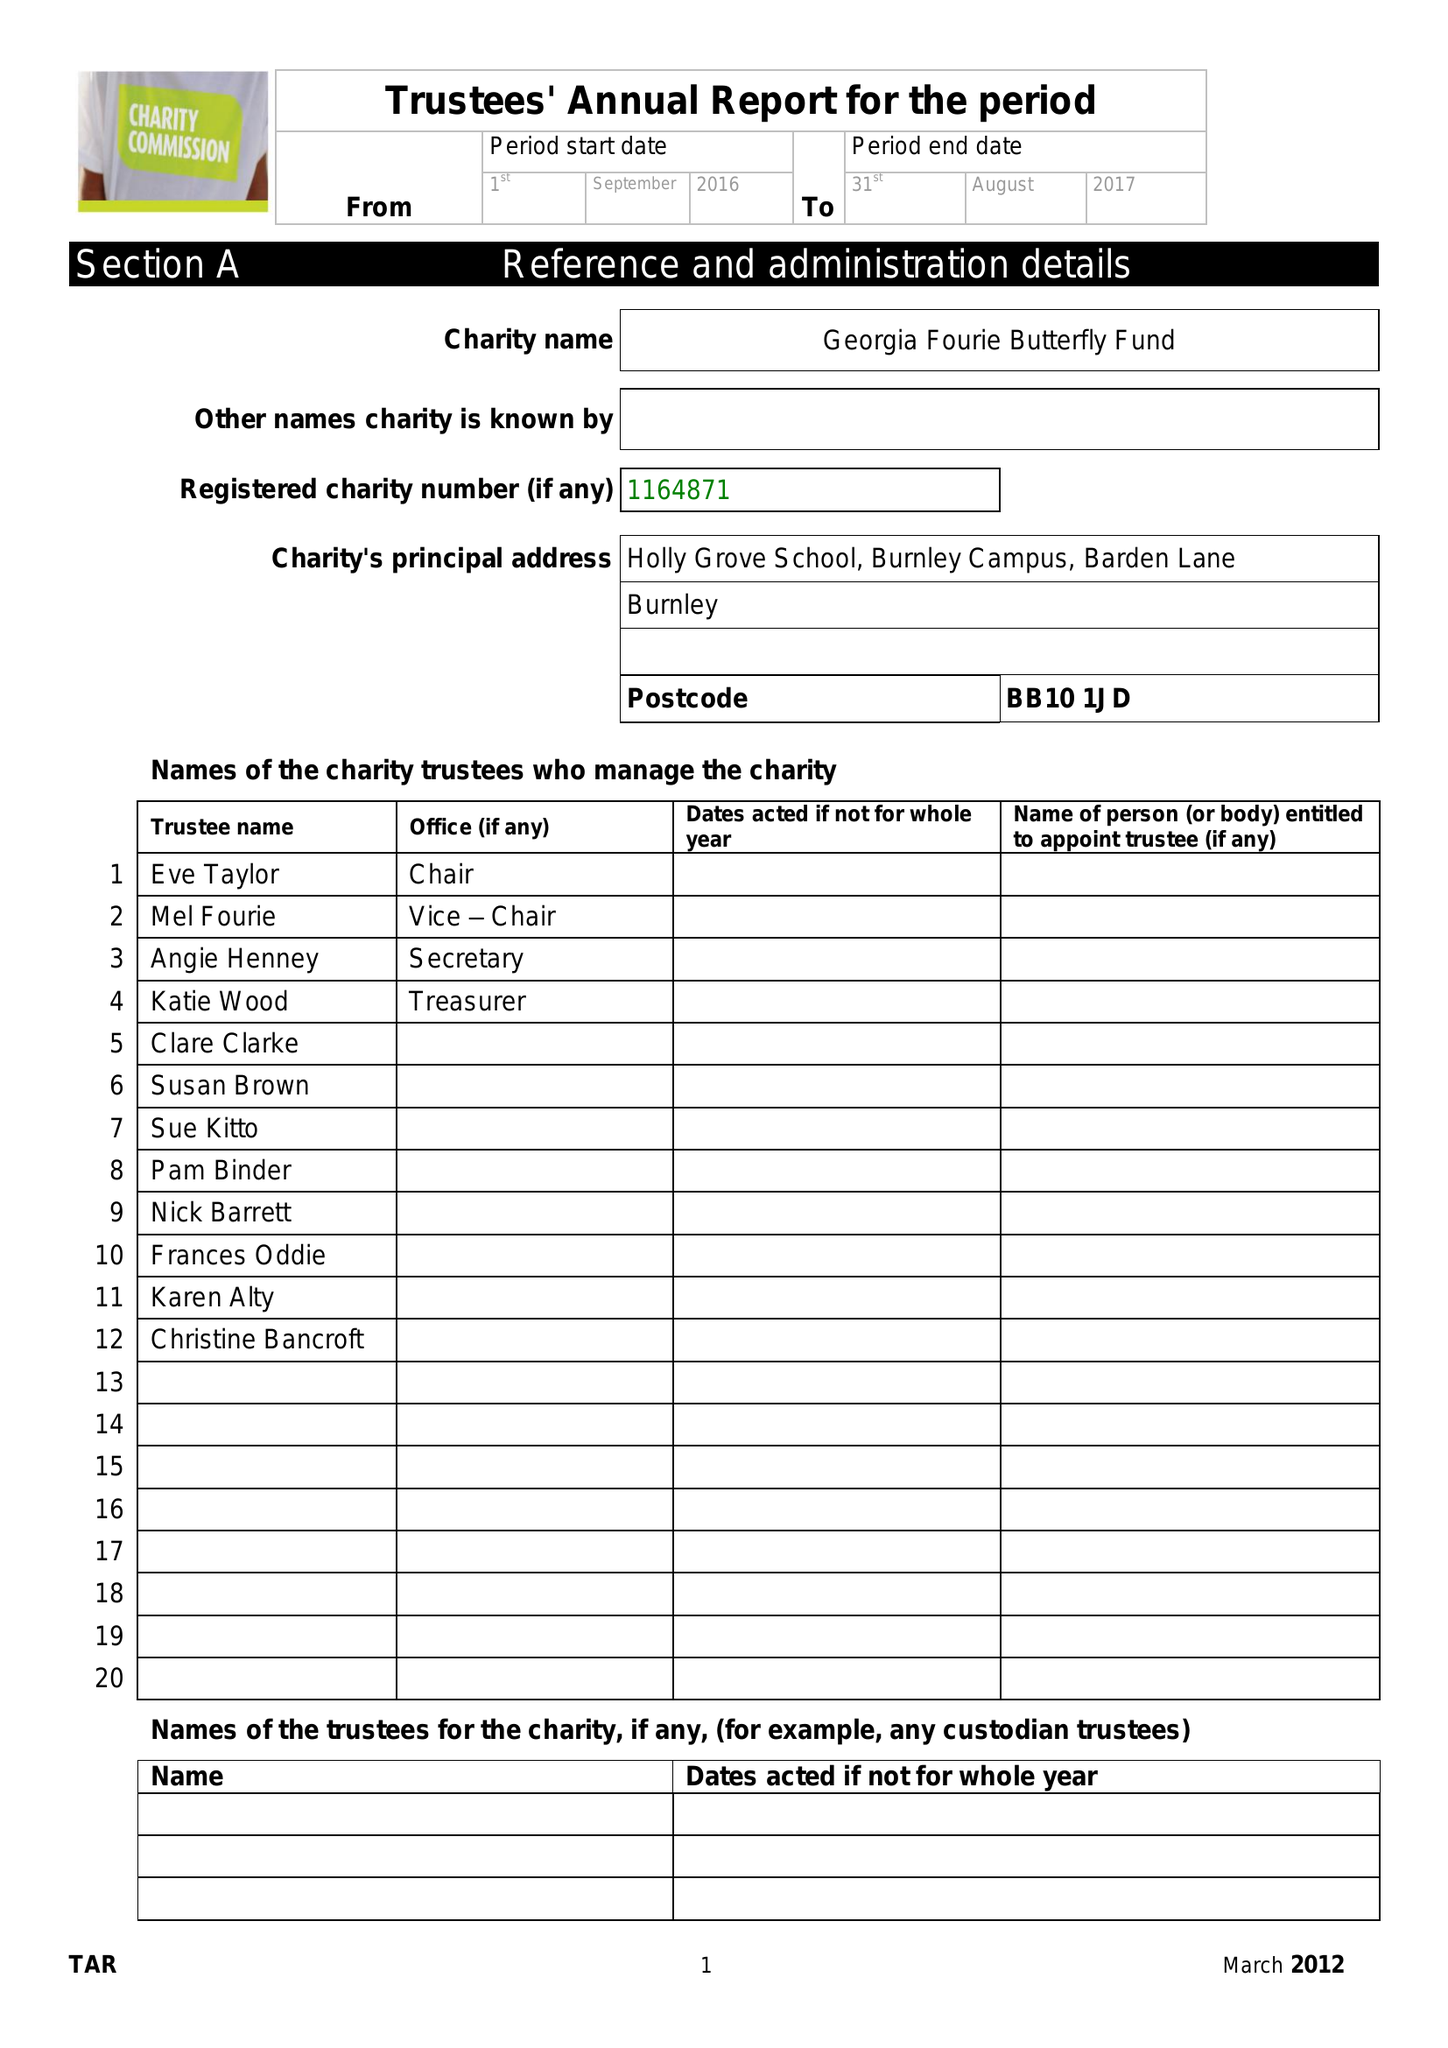What is the value for the address__street_line?
Answer the question using a single word or phrase. BARDEN LANE 